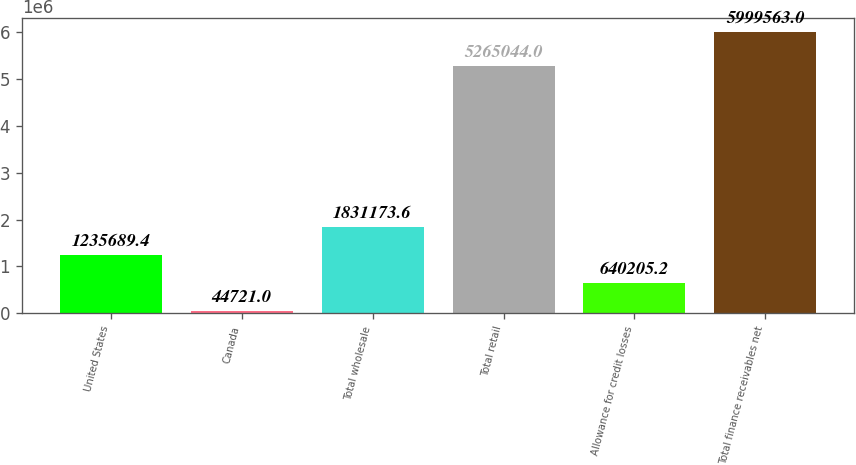Convert chart. <chart><loc_0><loc_0><loc_500><loc_500><bar_chart><fcel>United States<fcel>Canada<fcel>Total wholesale<fcel>Total retail<fcel>Allowance for credit losses<fcel>Total finance receivables net<nl><fcel>1.23569e+06<fcel>44721<fcel>1.83117e+06<fcel>5.26504e+06<fcel>640205<fcel>5.99956e+06<nl></chart> 